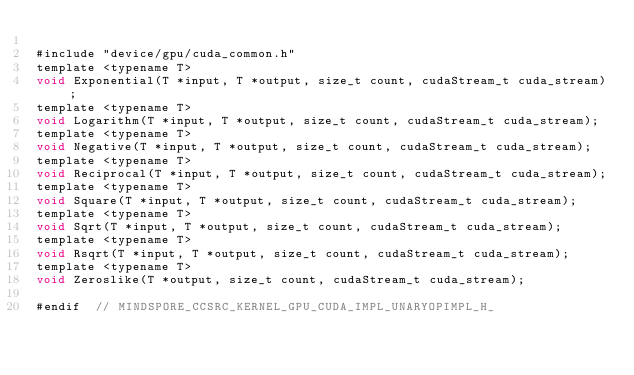Convert code to text. <code><loc_0><loc_0><loc_500><loc_500><_Cuda_>
#include "device/gpu/cuda_common.h"
template <typename T>
void Exponential(T *input, T *output, size_t count, cudaStream_t cuda_stream);
template <typename T>
void Logarithm(T *input, T *output, size_t count, cudaStream_t cuda_stream);
template <typename T>
void Negative(T *input, T *output, size_t count, cudaStream_t cuda_stream);
template <typename T>
void Reciprocal(T *input, T *output, size_t count, cudaStream_t cuda_stream);
template <typename T>
void Square(T *input, T *output, size_t count, cudaStream_t cuda_stream);
template <typename T>
void Sqrt(T *input, T *output, size_t count, cudaStream_t cuda_stream);
template <typename T>
void Rsqrt(T *input, T *output, size_t count, cudaStream_t cuda_stream);
template <typename T>
void Zeroslike(T *output, size_t count, cudaStream_t cuda_stream);

#endif  // MINDSPORE_CCSRC_KERNEL_GPU_CUDA_IMPL_UNARYOPIMPL_H_
</code> 